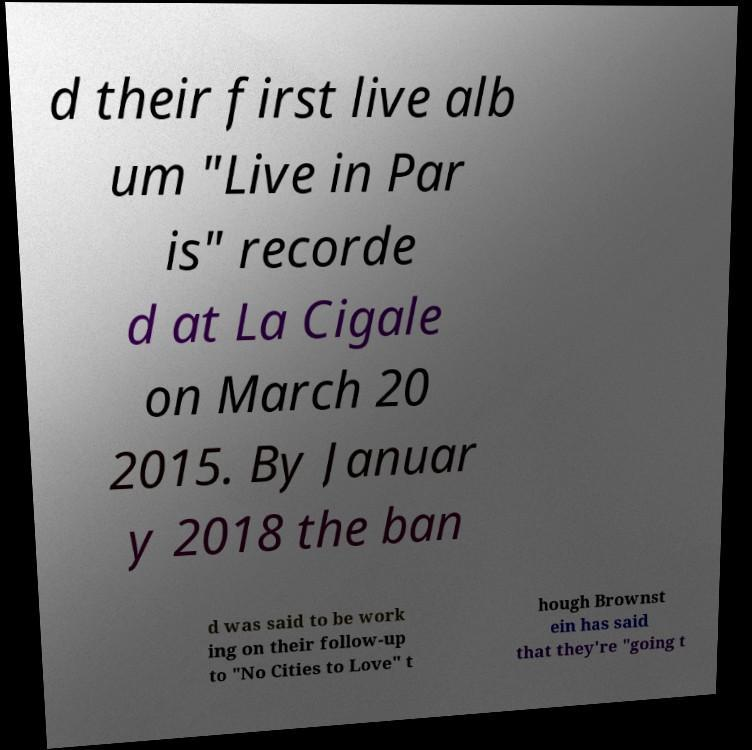Could you extract and type out the text from this image? d their first live alb um "Live in Par is" recorde d at La Cigale on March 20 2015. By Januar y 2018 the ban d was said to be work ing on their follow-up to "No Cities to Love" t hough Brownst ein has said that they're "going t 